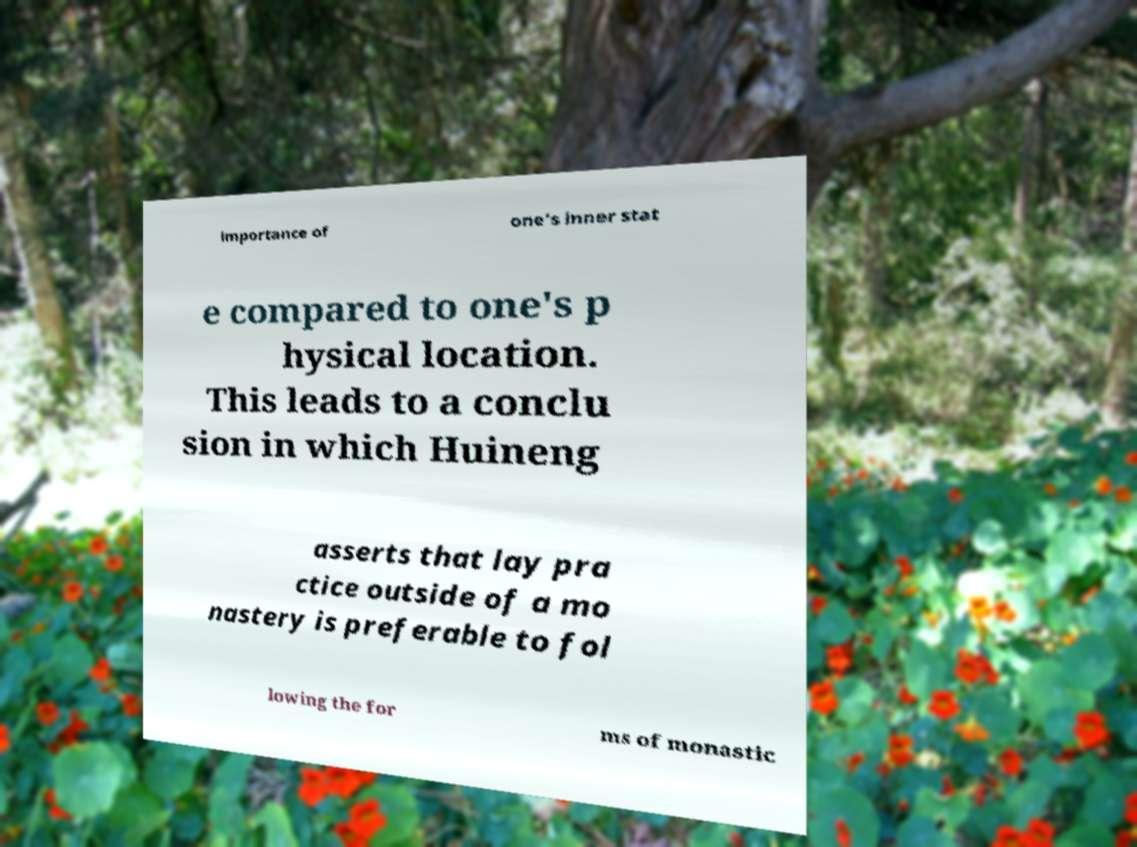Could you assist in decoding the text presented in this image and type it out clearly? importance of one's inner stat e compared to one's p hysical location. This leads to a conclu sion in which Huineng asserts that lay pra ctice outside of a mo nastery is preferable to fol lowing the for ms of monastic 